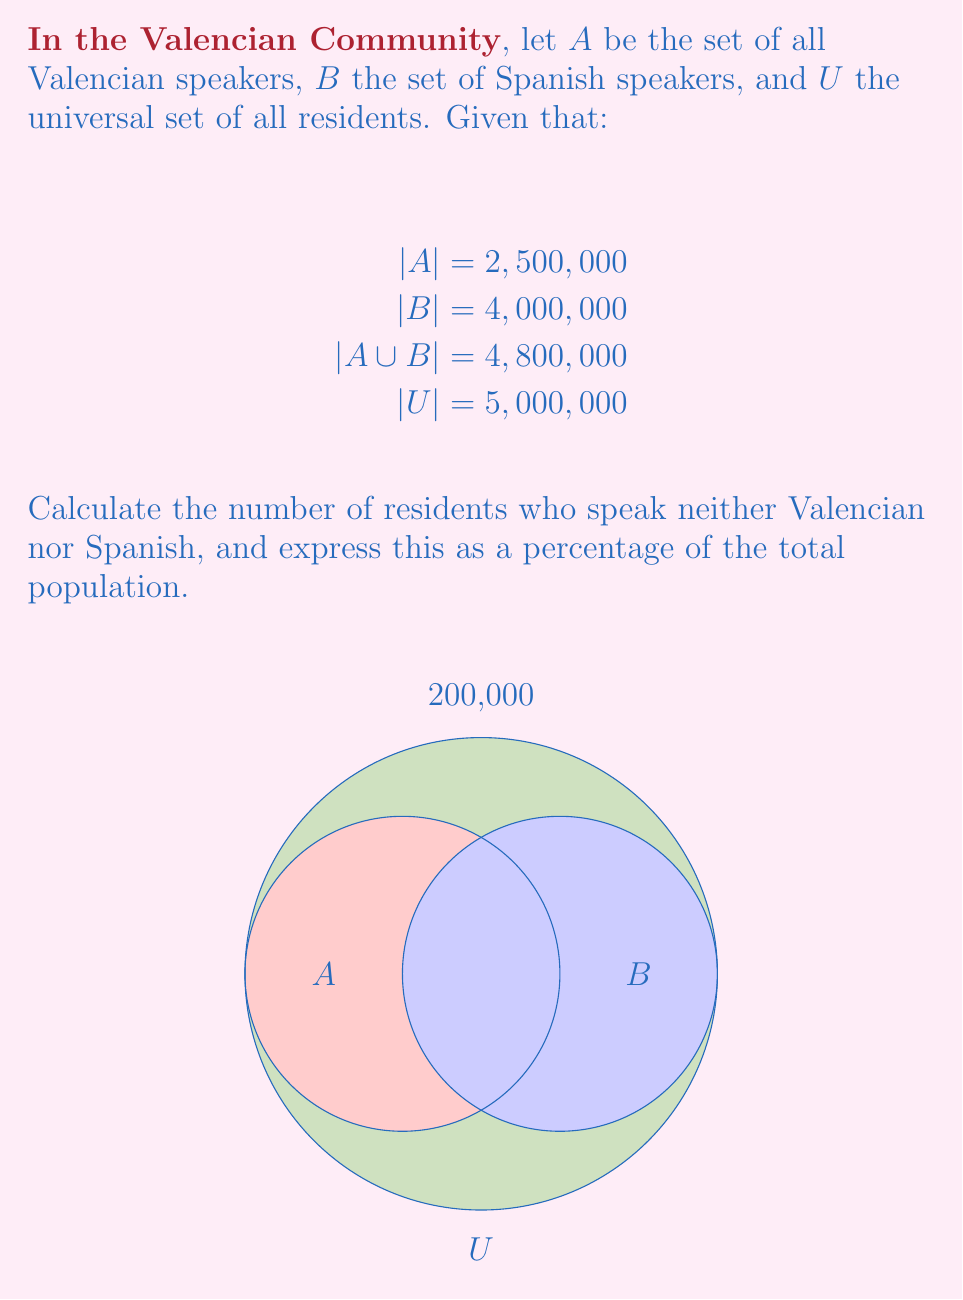What is the answer to this math problem? Let's approach this step-by-step using set theory:

1) First, we need to find the number of people who speak both Valencian and Spanish. We can use the formula:

   $$|A \cap B| = |A| + |B| - |A \cup B|$$

2) Substituting the given values:

   $$|A \cap B| = 2,500,000 + 4,000,000 - 4,800,000 = 1,700,000$$

3) Now, we can calculate the number of people who speak at least one of the languages:

   $$|A \cup B| = 4,800,000$$

4) To find the number of people who speak neither language, we subtract this from the total population:

   $$|U - (A \cup B)| = |U| - |A \cup B| = 5,000,000 - 4,800,000 = 200,000$$

5) To express this as a percentage of the total population:

   $$\text{Percentage} = \frac{200,000}{5,000,000} \times 100 = 4\%$$

Therefore, 200,000 residents (4% of the population) speak neither Valencian nor Spanish.
Answer: 200,000 (4%) 